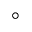Convert formula to latex. <formula><loc_0><loc_0><loc_500><loc_500>^ { \circ }</formula> 